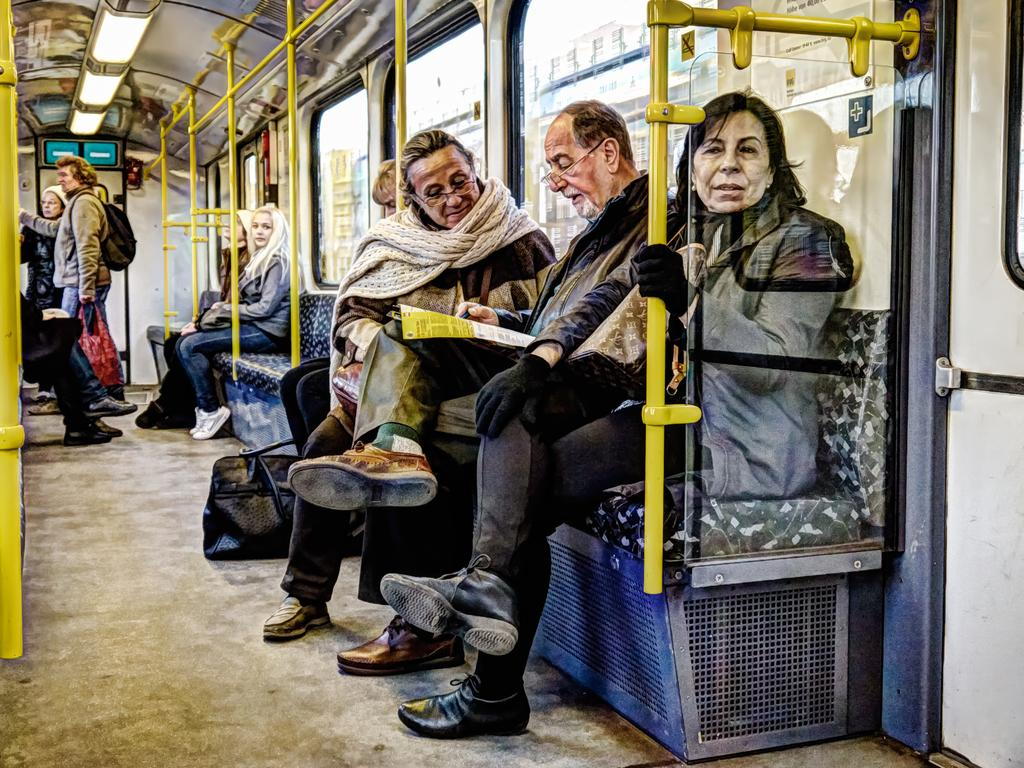What is the setting of the image? The image shows the inside of a vehicle. What are the people in the image doing? There are people standing and sitting on seats in the vehicle. What type of airplane is visible in the image? There is no airplane visible in the image; it shows the inside of a vehicle. How does the temper of the people in the image affect the vehicle's performance? The temper of the people in the image does not affect the vehicle's performance, as it is not mentioned in the facts provided. 